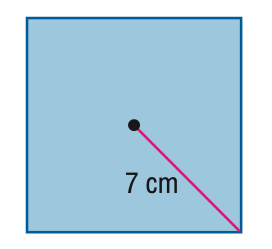Answer the mathemtical geometry problem and directly provide the correct option letter.
Question: Find the area of the regular polygon. Round to the nearest tenth.
Choices: A: 24.5 B: 49 C: 98 D: 392 C 